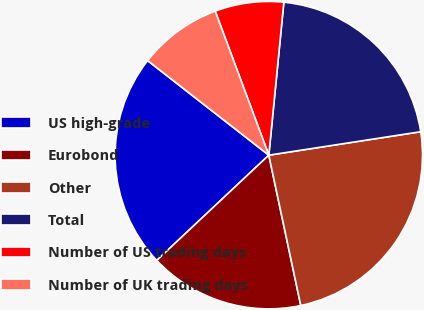<chart> <loc_0><loc_0><loc_500><loc_500><pie_chart><fcel>US high-grade<fcel>Eurobond<fcel>Other<fcel>Total<fcel>Number of US trading days<fcel>Number of UK trading days<nl><fcel>22.55%<fcel>16.33%<fcel>24.1%<fcel>21.0%<fcel>7.23%<fcel>8.78%<nl></chart> 